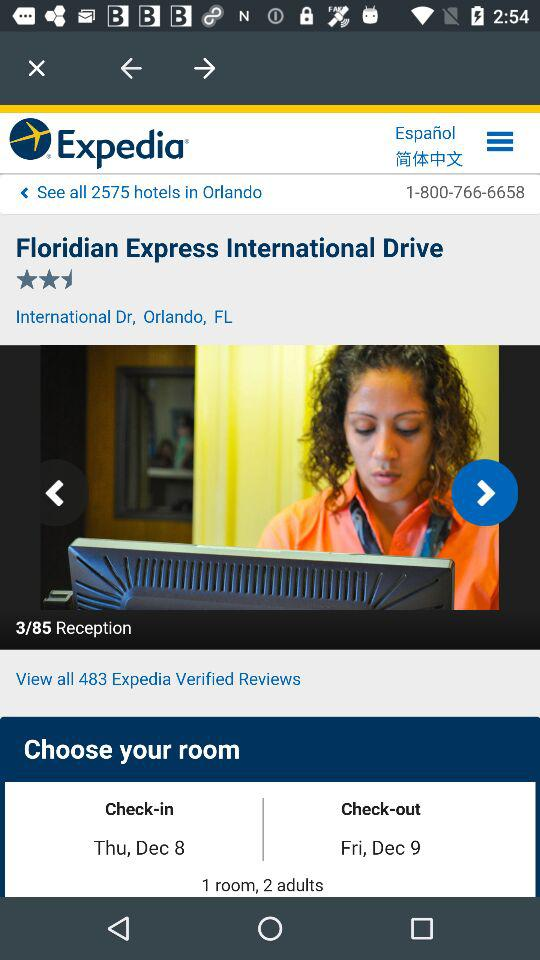What's the number of "Expedia" verified reviews? There are 483 verified reviews. 